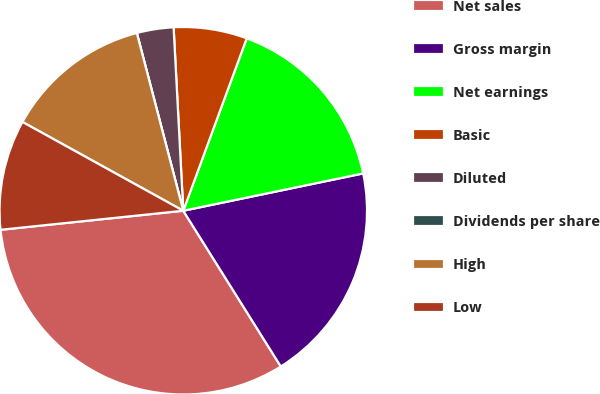Convert chart to OTSL. <chart><loc_0><loc_0><loc_500><loc_500><pie_chart><fcel>Net sales<fcel>Gross margin<fcel>Net earnings<fcel>Basic<fcel>Diluted<fcel>Dividends per share<fcel>High<fcel>Low<nl><fcel>32.25%<fcel>19.35%<fcel>16.13%<fcel>6.45%<fcel>3.23%<fcel>0.0%<fcel>12.9%<fcel>9.68%<nl></chart> 